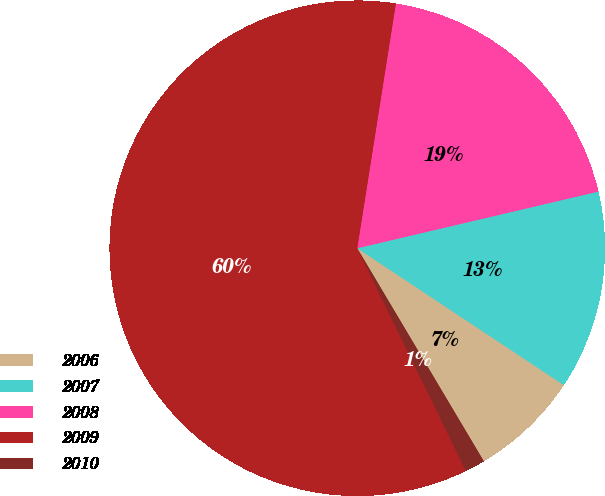<chart> <loc_0><loc_0><loc_500><loc_500><pie_chart><fcel>2006<fcel>2007<fcel>2008<fcel>2009<fcel>2010<nl><fcel>7.15%<fcel>12.99%<fcel>18.83%<fcel>59.71%<fcel>1.31%<nl></chart> 